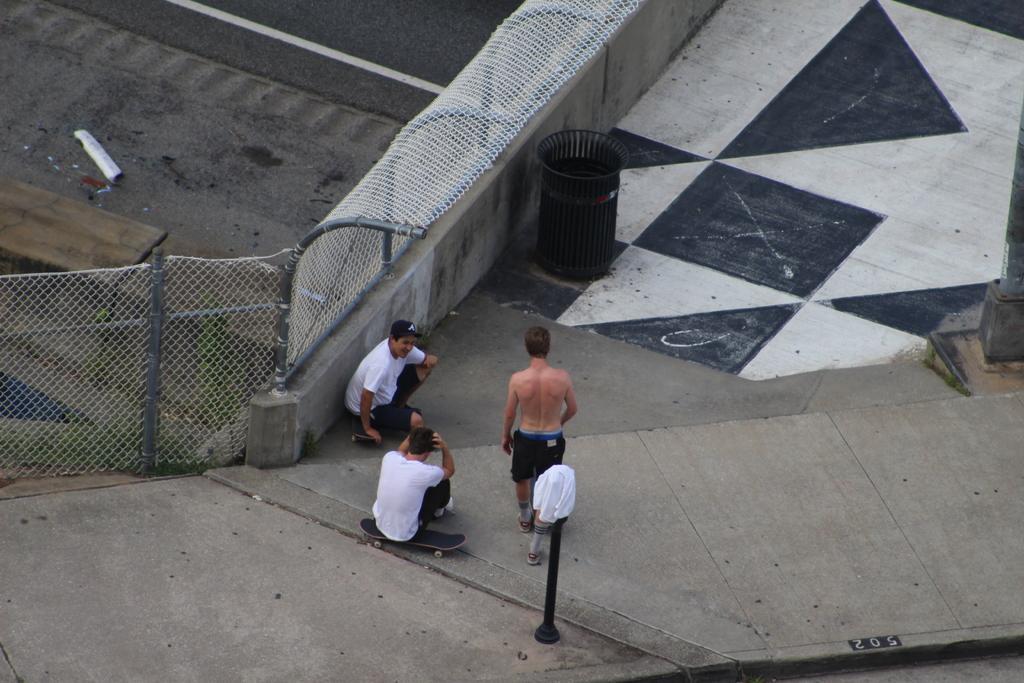Please provide a concise description of this image. This picture shows a couple of men seated on the skateboards on the ground and we see a man standing and we see a pole and a cloth on it and we see a metal fence and dustbin and a pole on the side and we see couple of men wore caps on their heads. 